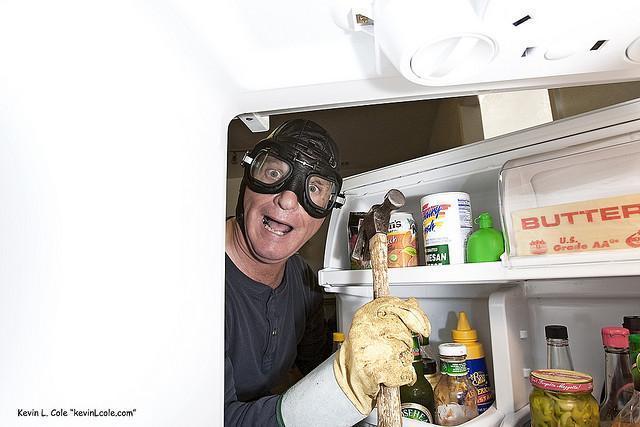How many bottles are there?
Give a very brief answer. 3. 